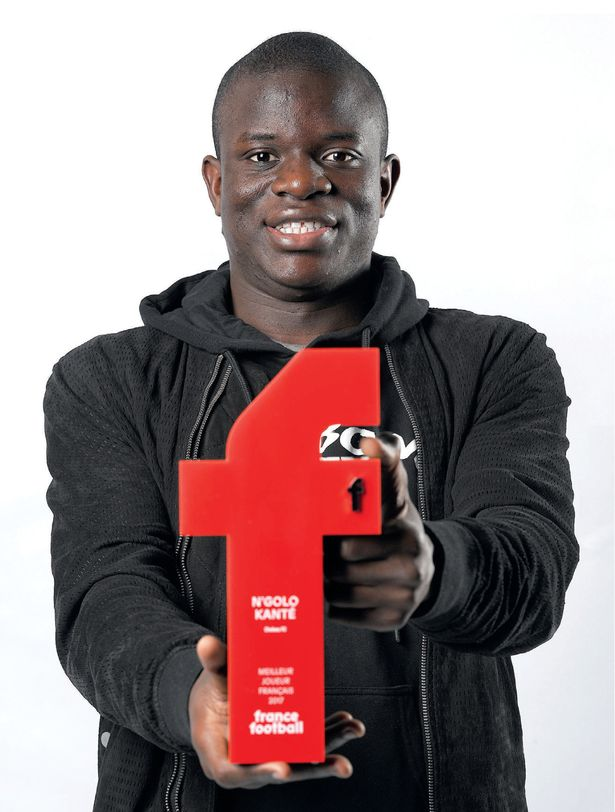Construct a detailed narrative exploring the life and challenges of this soccer player, focusing on a pivotal moment that led to receiving the 'Player of the Year' award. In the bustling streets of Paris, young dreams are born and nurtured on makeshift soccer fields. Among them was a boy whose passion for the game was unparalleled. From dawn till dusk, he practiced relentlessly, mimicking the moves of his idols. Despite facing numerous obstacles—limited resources, societal expectations, and the constant struggle to balance academics with his fervent commitment to soccer—his perseverance never waned.

One pivotal moment that defined his career came during a high-stakes championship match. His team was the underdog, facing a formidable opponent renowned for their tactical prowess. The game was intense, with both sides displaying extraordinary skill and determination. It was in the dying minutes, with the score deadlocked, that his moment of brilliance emerged. Seizing an opportunity, he orchestrated a breathtaking play, weaving through defenders with unparalleled agility and precision, and netting the decisive goal that clinched victory for his team.

This performance wasn't just about a goal; it was a testament to his evolution as a player—a synthesis of his technical skills, mental fortitude, and unwavering dedication. The audience, his teammates, and even his foes were left in awe. This match, a culmination of his journey filled with hardships and triumphs, played a significant role in his recognition as the 'Player of the Year.'

Receiving this esteemed award was more than an individual accolade; it was a reflection of his relentless pursuit of excellence and the sacrifices made along the way. It underscored every early morning practice, every moment of doubt overcome, and every challenge faced head-on. As he stood on that stage, holding the award, the culmination of his life's dedication to soccer, he knew this was not just an end, but a new beginning, inspiring countless others to dream and persevere. 